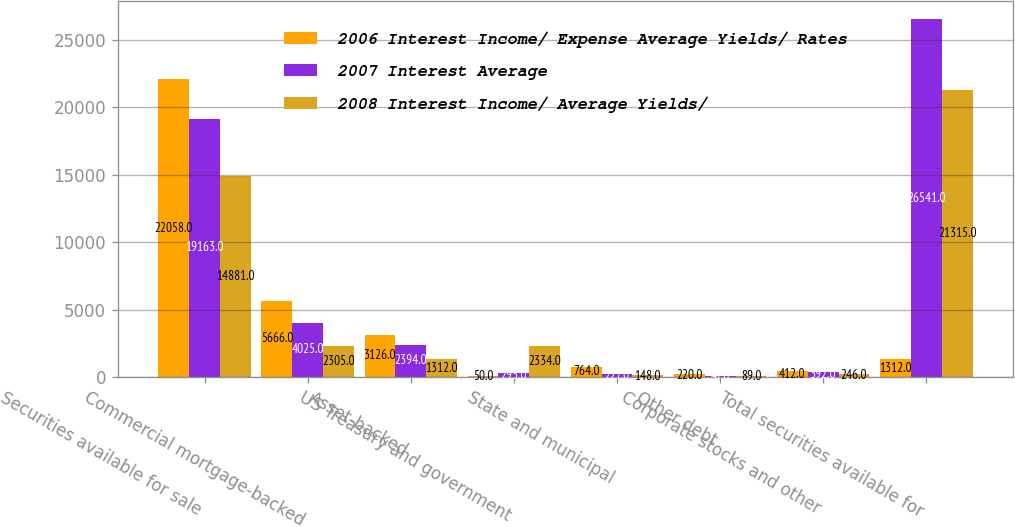Convert chart to OTSL. <chart><loc_0><loc_0><loc_500><loc_500><stacked_bar_chart><ecel><fcel>Securities available for sale<fcel>Commercial mortgage-backed<fcel>Asset-backed<fcel>US Treasury and government<fcel>State and municipal<fcel>Other debt<fcel>Corporate stocks and other<fcel>Total securities available for<nl><fcel>2006 Interest Income/ Expense Average Yields/ Rates<fcel>22058<fcel>5666<fcel>3126<fcel>50<fcel>764<fcel>220<fcel>412<fcel>1312<nl><fcel>2007 Interest Average<fcel>19163<fcel>4025<fcel>2394<fcel>293<fcel>227<fcel>47<fcel>392<fcel>26541<nl><fcel>2008 Interest Income/ Average Yields/<fcel>14881<fcel>2305<fcel>1312<fcel>2334<fcel>148<fcel>89<fcel>246<fcel>21315<nl></chart> 